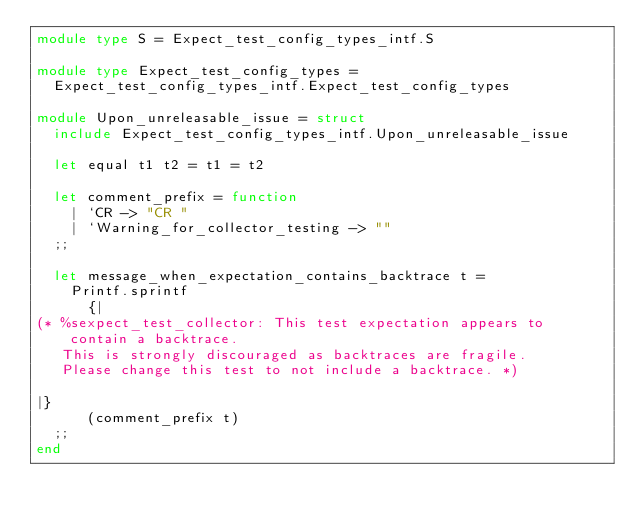<code> <loc_0><loc_0><loc_500><loc_500><_OCaml_>module type S = Expect_test_config_types_intf.S

module type Expect_test_config_types =
  Expect_test_config_types_intf.Expect_test_config_types

module Upon_unreleasable_issue = struct
  include Expect_test_config_types_intf.Upon_unreleasable_issue

  let equal t1 t2 = t1 = t2

  let comment_prefix = function
    | `CR -> "CR "
    | `Warning_for_collector_testing -> ""
  ;;

  let message_when_expectation_contains_backtrace t =
    Printf.sprintf
      {|
(* %sexpect_test_collector: This test expectation appears to contain a backtrace.
   This is strongly discouraged as backtraces are fragile.
   Please change this test to not include a backtrace. *)

|}
      (comment_prefix t)
  ;;
end
</code> 